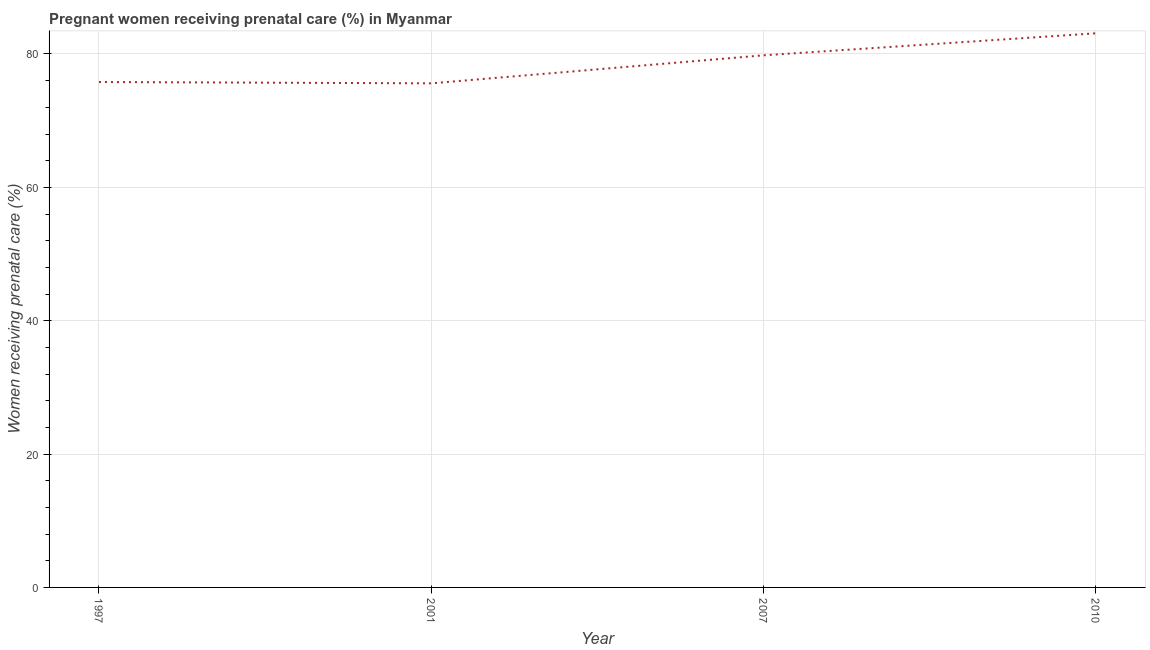What is the percentage of pregnant women receiving prenatal care in 2010?
Your response must be concise. 83.1. Across all years, what is the maximum percentage of pregnant women receiving prenatal care?
Offer a terse response. 83.1. Across all years, what is the minimum percentage of pregnant women receiving prenatal care?
Make the answer very short. 75.6. What is the sum of the percentage of pregnant women receiving prenatal care?
Your answer should be very brief. 314.3. What is the difference between the percentage of pregnant women receiving prenatal care in 2001 and 2010?
Your response must be concise. -7.5. What is the average percentage of pregnant women receiving prenatal care per year?
Provide a short and direct response. 78.57. What is the median percentage of pregnant women receiving prenatal care?
Ensure brevity in your answer.  77.8. Do a majority of the years between 2010 and 2001 (inclusive) have percentage of pregnant women receiving prenatal care greater than 64 %?
Your answer should be compact. No. What is the ratio of the percentage of pregnant women receiving prenatal care in 2001 to that in 2010?
Offer a terse response. 0.91. Is the difference between the percentage of pregnant women receiving prenatal care in 2001 and 2007 greater than the difference between any two years?
Your response must be concise. No. What is the difference between the highest and the second highest percentage of pregnant women receiving prenatal care?
Ensure brevity in your answer.  3.3. Is the sum of the percentage of pregnant women receiving prenatal care in 1997 and 2010 greater than the maximum percentage of pregnant women receiving prenatal care across all years?
Provide a short and direct response. Yes. How many lines are there?
Offer a terse response. 1. How many years are there in the graph?
Offer a very short reply. 4. What is the difference between two consecutive major ticks on the Y-axis?
Provide a short and direct response. 20. What is the title of the graph?
Your answer should be very brief. Pregnant women receiving prenatal care (%) in Myanmar. What is the label or title of the X-axis?
Offer a very short reply. Year. What is the label or title of the Y-axis?
Your answer should be compact. Women receiving prenatal care (%). What is the Women receiving prenatal care (%) in 1997?
Make the answer very short. 75.8. What is the Women receiving prenatal care (%) of 2001?
Your response must be concise. 75.6. What is the Women receiving prenatal care (%) of 2007?
Make the answer very short. 79.8. What is the Women receiving prenatal care (%) of 2010?
Offer a terse response. 83.1. What is the difference between the Women receiving prenatal care (%) in 1997 and 2001?
Offer a very short reply. 0.2. What is the difference between the Women receiving prenatal care (%) in 2001 and 2007?
Your response must be concise. -4.2. What is the difference between the Women receiving prenatal care (%) in 2001 and 2010?
Give a very brief answer. -7.5. What is the difference between the Women receiving prenatal care (%) in 2007 and 2010?
Keep it short and to the point. -3.3. What is the ratio of the Women receiving prenatal care (%) in 1997 to that in 2010?
Keep it short and to the point. 0.91. What is the ratio of the Women receiving prenatal care (%) in 2001 to that in 2007?
Your answer should be compact. 0.95. What is the ratio of the Women receiving prenatal care (%) in 2001 to that in 2010?
Make the answer very short. 0.91. 